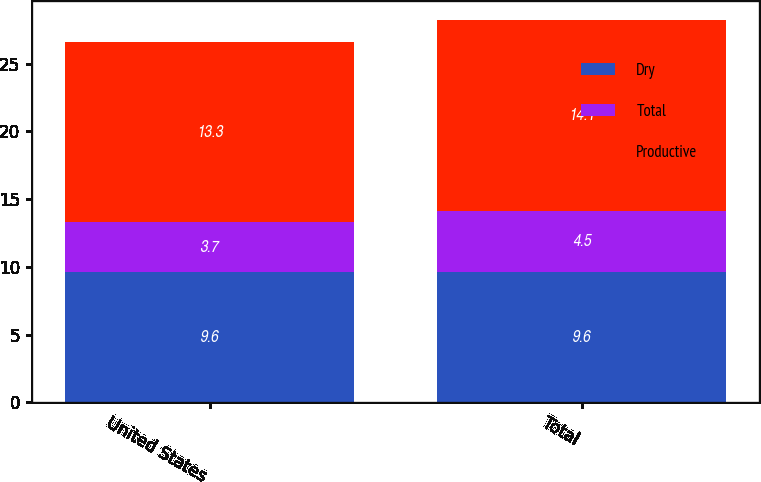<chart> <loc_0><loc_0><loc_500><loc_500><stacked_bar_chart><ecel><fcel>United States<fcel>Total<nl><fcel>Dry<fcel>9.6<fcel>9.6<nl><fcel>Total<fcel>3.7<fcel>4.5<nl><fcel>Productive<fcel>13.3<fcel>14.1<nl></chart> 